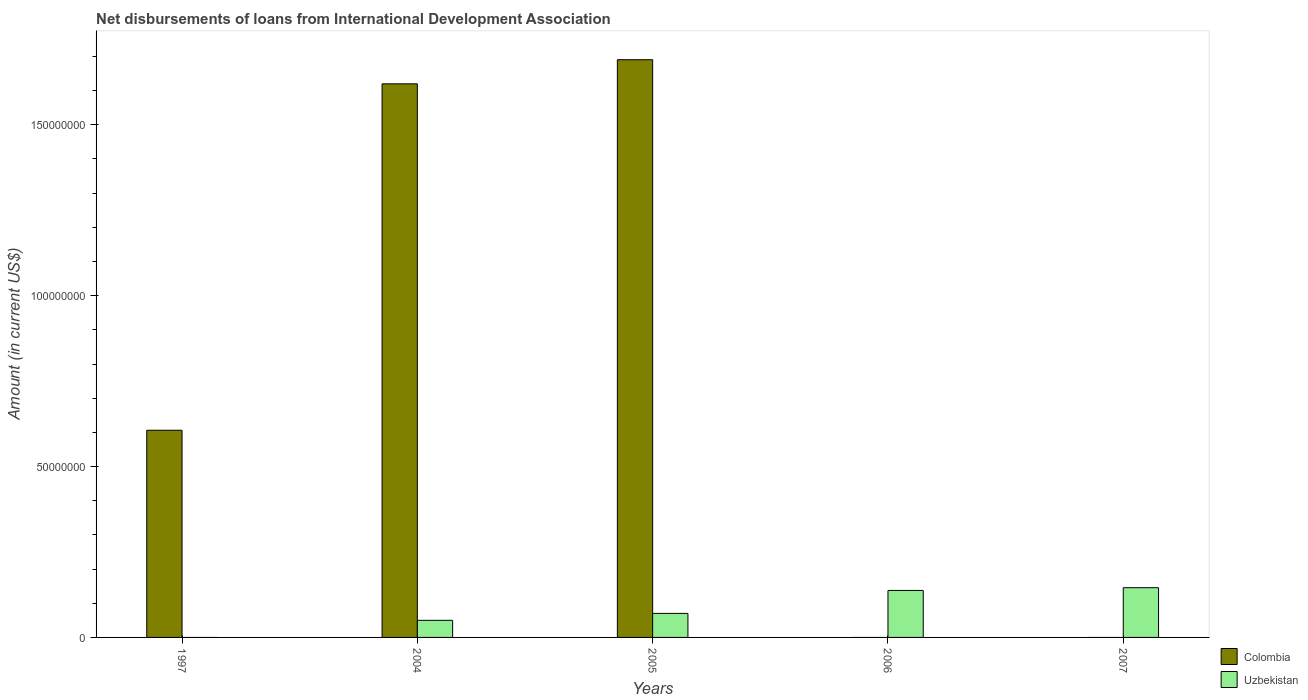Are the number of bars per tick equal to the number of legend labels?
Offer a terse response. No. How many bars are there on the 1st tick from the right?
Provide a succinct answer. 1. What is the amount of loans disbursed in Uzbekistan in 2005?
Your response must be concise. 7.03e+06. Across all years, what is the maximum amount of loans disbursed in Uzbekistan?
Make the answer very short. 1.46e+07. In which year was the amount of loans disbursed in Uzbekistan maximum?
Your answer should be compact. 2007. What is the total amount of loans disbursed in Colombia in the graph?
Give a very brief answer. 3.92e+08. What is the difference between the amount of loans disbursed in Colombia in 2004 and that in 2005?
Make the answer very short. -7.06e+06. What is the difference between the amount of loans disbursed in Uzbekistan in 1997 and the amount of loans disbursed in Colombia in 2006?
Provide a succinct answer. 0. What is the average amount of loans disbursed in Colombia per year?
Keep it short and to the point. 7.83e+07. In the year 2004, what is the difference between the amount of loans disbursed in Colombia and amount of loans disbursed in Uzbekistan?
Keep it short and to the point. 1.57e+08. What is the ratio of the amount of loans disbursed in Colombia in 2004 to that in 2005?
Offer a very short reply. 0.96. Is the amount of loans disbursed in Colombia in 1997 less than that in 2004?
Your response must be concise. Yes. What is the difference between the highest and the second highest amount of loans disbursed in Colombia?
Your answer should be compact. 7.06e+06. What is the difference between the highest and the lowest amount of loans disbursed in Uzbekistan?
Provide a succinct answer. 1.46e+07. In how many years, is the amount of loans disbursed in Colombia greater than the average amount of loans disbursed in Colombia taken over all years?
Give a very brief answer. 2. Is the sum of the amount of loans disbursed in Uzbekistan in 2004 and 2005 greater than the maximum amount of loans disbursed in Colombia across all years?
Keep it short and to the point. No. Does the graph contain grids?
Ensure brevity in your answer.  No. Where does the legend appear in the graph?
Give a very brief answer. Bottom right. How many legend labels are there?
Your answer should be compact. 2. What is the title of the graph?
Keep it short and to the point. Net disbursements of loans from International Development Association. Does "Niger" appear as one of the legend labels in the graph?
Ensure brevity in your answer.  No. What is the label or title of the Y-axis?
Your answer should be very brief. Amount (in current US$). What is the Amount (in current US$) in Colombia in 1997?
Make the answer very short. 6.06e+07. What is the Amount (in current US$) of Uzbekistan in 1997?
Give a very brief answer. 0. What is the Amount (in current US$) of Colombia in 2004?
Your answer should be compact. 1.62e+08. What is the Amount (in current US$) in Colombia in 2005?
Ensure brevity in your answer.  1.69e+08. What is the Amount (in current US$) of Uzbekistan in 2005?
Your response must be concise. 7.03e+06. What is the Amount (in current US$) in Colombia in 2006?
Your response must be concise. 0. What is the Amount (in current US$) in Uzbekistan in 2006?
Keep it short and to the point. 1.37e+07. What is the Amount (in current US$) in Colombia in 2007?
Offer a very short reply. 0. What is the Amount (in current US$) of Uzbekistan in 2007?
Ensure brevity in your answer.  1.46e+07. Across all years, what is the maximum Amount (in current US$) of Colombia?
Ensure brevity in your answer.  1.69e+08. Across all years, what is the maximum Amount (in current US$) of Uzbekistan?
Offer a terse response. 1.46e+07. Across all years, what is the minimum Amount (in current US$) of Colombia?
Ensure brevity in your answer.  0. What is the total Amount (in current US$) in Colombia in the graph?
Your answer should be compact. 3.92e+08. What is the total Amount (in current US$) in Uzbekistan in the graph?
Ensure brevity in your answer.  4.03e+07. What is the difference between the Amount (in current US$) in Colombia in 1997 and that in 2004?
Provide a succinct answer. -1.01e+08. What is the difference between the Amount (in current US$) in Colombia in 1997 and that in 2005?
Offer a terse response. -1.08e+08. What is the difference between the Amount (in current US$) in Colombia in 2004 and that in 2005?
Keep it short and to the point. -7.06e+06. What is the difference between the Amount (in current US$) in Uzbekistan in 2004 and that in 2005?
Keep it short and to the point. -2.03e+06. What is the difference between the Amount (in current US$) of Uzbekistan in 2004 and that in 2006?
Provide a succinct answer. -8.75e+06. What is the difference between the Amount (in current US$) in Uzbekistan in 2004 and that in 2007?
Ensure brevity in your answer.  -9.55e+06. What is the difference between the Amount (in current US$) of Uzbekistan in 2005 and that in 2006?
Keep it short and to the point. -6.72e+06. What is the difference between the Amount (in current US$) of Uzbekistan in 2005 and that in 2007?
Your answer should be compact. -7.52e+06. What is the difference between the Amount (in current US$) of Uzbekistan in 2006 and that in 2007?
Make the answer very short. -8.05e+05. What is the difference between the Amount (in current US$) in Colombia in 1997 and the Amount (in current US$) in Uzbekistan in 2004?
Give a very brief answer. 5.56e+07. What is the difference between the Amount (in current US$) of Colombia in 1997 and the Amount (in current US$) of Uzbekistan in 2005?
Provide a short and direct response. 5.36e+07. What is the difference between the Amount (in current US$) of Colombia in 1997 and the Amount (in current US$) of Uzbekistan in 2006?
Your response must be concise. 4.69e+07. What is the difference between the Amount (in current US$) of Colombia in 1997 and the Amount (in current US$) of Uzbekistan in 2007?
Your response must be concise. 4.61e+07. What is the difference between the Amount (in current US$) of Colombia in 2004 and the Amount (in current US$) of Uzbekistan in 2005?
Keep it short and to the point. 1.55e+08. What is the difference between the Amount (in current US$) of Colombia in 2004 and the Amount (in current US$) of Uzbekistan in 2006?
Your answer should be very brief. 1.48e+08. What is the difference between the Amount (in current US$) in Colombia in 2004 and the Amount (in current US$) in Uzbekistan in 2007?
Provide a succinct answer. 1.47e+08. What is the difference between the Amount (in current US$) in Colombia in 2005 and the Amount (in current US$) in Uzbekistan in 2006?
Provide a short and direct response. 1.55e+08. What is the difference between the Amount (in current US$) in Colombia in 2005 and the Amount (in current US$) in Uzbekistan in 2007?
Ensure brevity in your answer.  1.54e+08. What is the average Amount (in current US$) of Colombia per year?
Offer a terse response. 7.83e+07. What is the average Amount (in current US$) of Uzbekistan per year?
Offer a very short reply. 8.07e+06. In the year 2004, what is the difference between the Amount (in current US$) of Colombia and Amount (in current US$) of Uzbekistan?
Ensure brevity in your answer.  1.57e+08. In the year 2005, what is the difference between the Amount (in current US$) in Colombia and Amount (in current US$) in Uzbekistan?
Make the answer very short. 1.62e+08. What is the ratio of the Amount (in current US$) in Colombia in 1997 to that in 2004?
Ensure brevity in your answer.  0.37. What is the ratio of the Amount (in current US$) of Colombia in 1997 to that in 2005?
Make the answer very short. 0.36. What is the ratio of the Amount (in current US$) of Colombia in 2004 to that in 2005?
Keep it short and to the point. 0.96. What is the ratio of the Amount (in current US$) in Uzbekistan in 2004 to that in 2005?
Make the answer very short. 0.71. What is the ratio of the Amount (in current US$) of Uzbekistan in 2004 to that in 2006?
Provide a short and direct response. 0.36. What is the ratio of the Amount (in current US$) of Uzbekistan in 2004 to that in 2007?
Keep it short and to the point. 0.34. What is the ratio of the Amount (in current US$) in Uzbekistan in 2005 to that in 2006?
Provide a short and direct response. 0.51. What is the ratio of the Amount (in current US$) in Uzbekistan in 2005 to that in 2007?
Your answer should be compact. 0.48. What is the ratio of the Amount (in current US$) of Uzbekistan in 2006 to that in 2007?
Offer a very short reply. 0.94. What is the difference between the highest and the second highest Amount (in current US$) of Colombia?
Provide a short and direct response. 7.06e+06. What is the difference between the highest and the second highest Amount (in current US$) of Uzbekistan?
Provide a short and direct response. 8.05e+05. What is the difference between the highest and the lowest Amount (in current US$) of Colombia?
Ensure brevity in your answer.  1.69e+08. What is the difference between the highest and the lowest Amount (in current US$) of Uzbekistan?
Offer a terse response. 1.46e+07. 